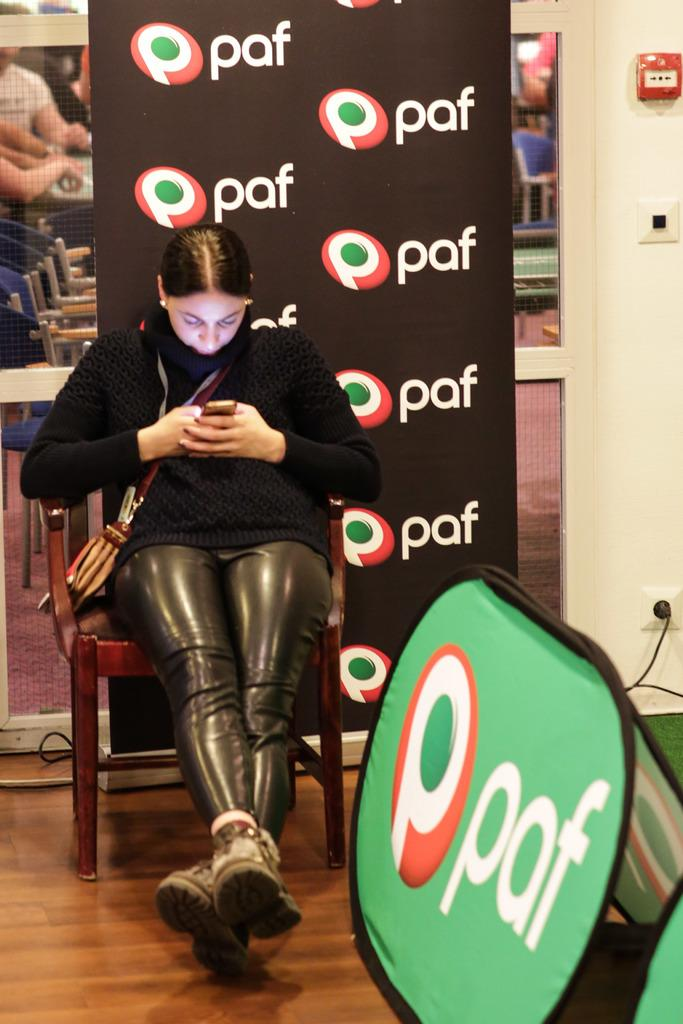Who is present in the image? There is a woman in the image. What is the woman doing in the image? The woman is sitting on a chair. What can be seen in the background of the image? There is a black color hoarding in the image. What is written on the hoarding? The hoarding has the text "paf" written on it. Can you hear the woman crying in the image? There is no indication of the woman crying in the image, as it only shows her sitting on a chair. 